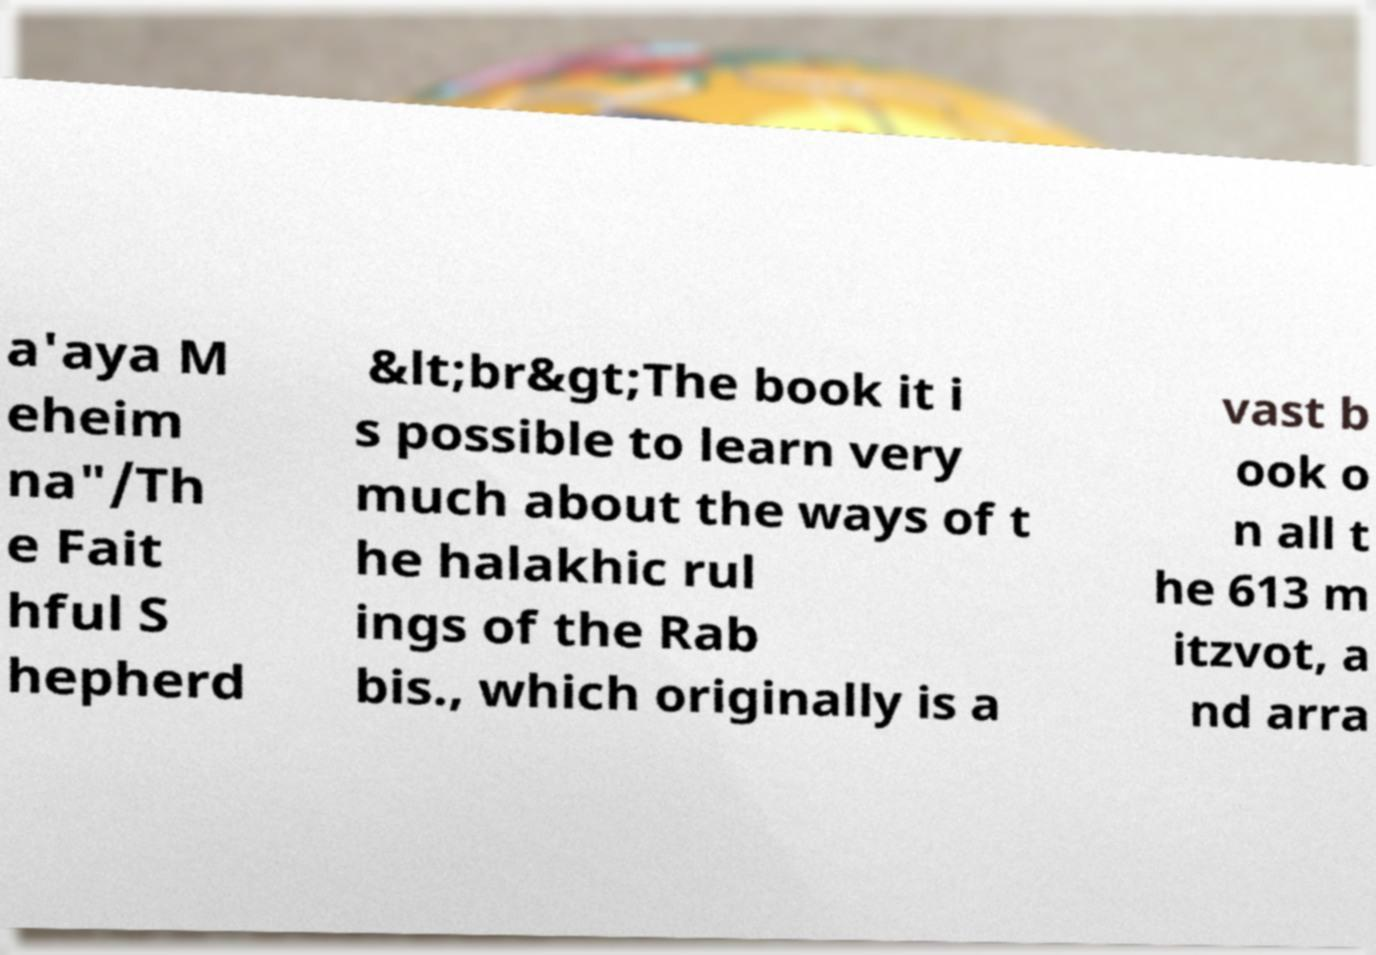For documentation purposes, I need the text within this image transcribed. Could you provide that? a'aya M eheim na"/Th e Fait hful S hepherd &lt;br&gt;The book it i s possible to learn very much about the ways of t he halakhic rul ings of the Rab bis., which originally is a vast b ook o n all t he 613 m itzvot, a nd arra 